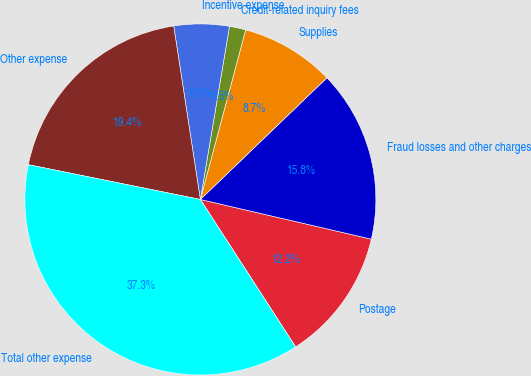<chart> <loc_0><loc_0><loc_500><loc_500><pie_chart><fcel>Postage<fcel>Fraud losses and other charges<fcel>Supplies<fcel>Credit-related inquiry fees<fcel>Incentive expense<fcel>Other expense<fcel>Total other expense<nl><fcel>12.24%<fcel>15.82%<fcel>8.66%<fcel>1.5%<fcel>5.08%<fcel>19.4%<fcel>37.31%<nl></chart> 